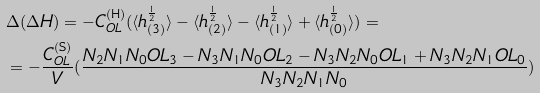Convert formula to latex. <formula><loc_0><loc_0><loc_500><loc_500>& \Delta ( \Delta H ) = - C _ { O L } ^ { ( \text {H} ) } ( \langle h _ { ( 3 ) } ^ { \frac { 1 } { 2 } } \rangle - \langle h _ { ( 2 ) } ^ { \frac { 1 } { 2 } } \rangle - \langle h _ { ( 1 ) } ^ { \frac { 1 } { 2 } } \rangle + \langle h _ { ( 0 ) } ^ { \frac { 1 } { 2 } } \rangle ) = \\ & = - \frac { C _ { O L } ^ { ( \text {S} ) } } { V } ( \frac { N _ { 2 } N _ { 1 } N _ { 0 } O L _ { 3 } - N _ { 3 } N _ { 1 } N _ { 0 } O L _ { 2 } - N _ { 3 } N _ { 2 } N _ { 0 } O L _ { 1 } + N _ { 3 } N _ { 2 } N _ { 1 } O L _ { 0 } } { N _ { 3 } N _ { 2 } N _ { 1 } N _ { 0 } } )</formula> 